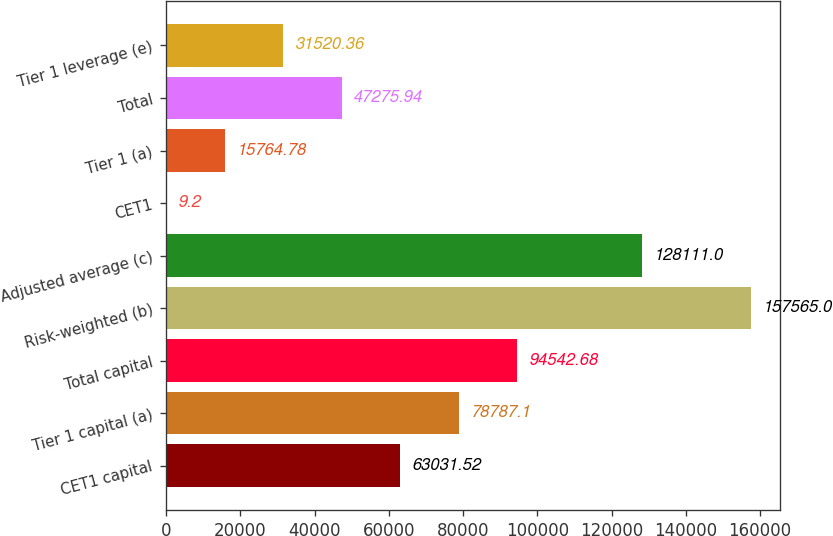Convert chart to OTSL. <chart><loc_0><loc_0><loc_500><loc_500><bar_chart><fcel>CET1 capital<fcel>Tier 1 capital (a)<fcel>Total capital<fcel>Risk-weighted (b)<fcel>Adjusted average (c)<fcel>CET1<fcel>Tier 1 (a)<fcel>Total<fcel>Tier 1 leverage (e)<nl><fcel>63031.5<fcel>78787.1<fcel>94542.7<fcel>157565<fcel>128111<fcel>9.2<fcel>15764.8<fcel>47275.9<fcel>31520.4<nl></chart> 